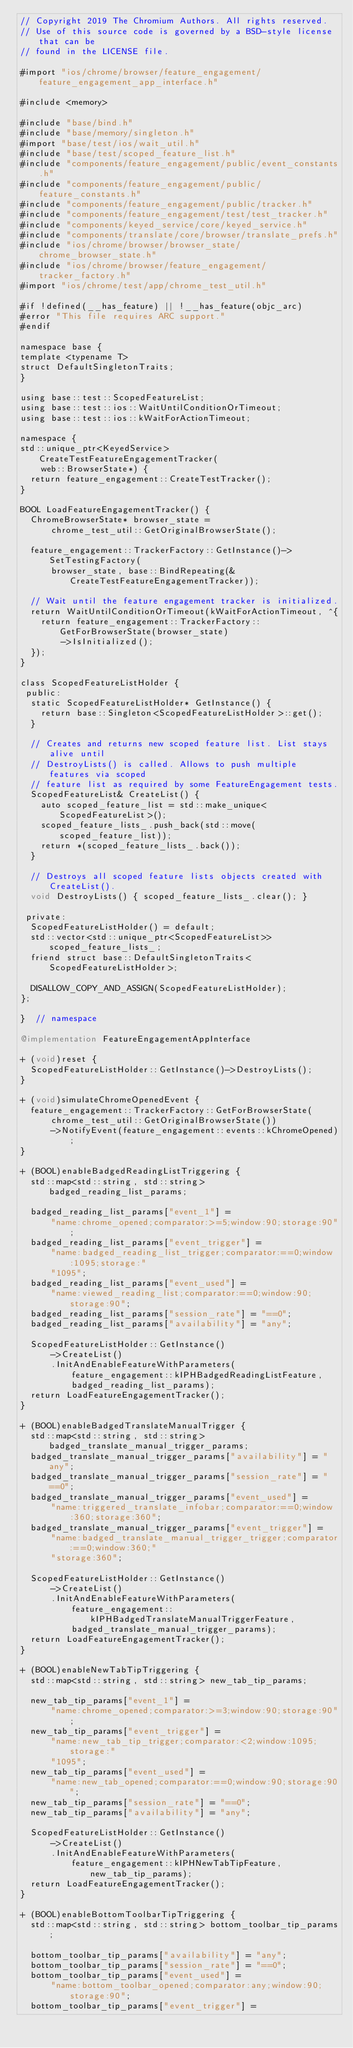<code> <loc_0><loc_0><loc_500><loc_500><_ObjectiveC_>// Copyright 2019 The Chromium Authors. All rights reserved.
// Use of this source code is governed by a BSD-style license that can be
// found in the LICENSE file.

#import "ios/chrome/browser/feature_engagement/feature_engagement_app_interface.h"

#include <memory>

#include "base/bind.h"
#include "base/memory/singleton.h"
#import "base/test/ios/wait_util.h"
#include "base/test/scoped_feature_list.h"
#include "components/feature_engagement/public/event_constants.h"
#include "components/feature_engagement/public/feature_constants.h"
#include "components/feature_engagement/public/tracker.h"
#include "components/feature_engagement/test/test_tracker.h"
#include "components/keyed_service/core/keyed_service.h"
#include "components/translate/core/browser/translate_prefs.h"
#include "ios/chrome/browser/browser_state/chrome_browser_state.h"
#include "ios/chrome/browser/feature_engagement/tracker_factory.h"
#import "ios/chrome/test/app/chrome_test_util.h"

#if !defined(__has_feature) || !__has_feature(objc_arc)
#error "This file requires ARC support."
#endif

namespace base {
template <typename T>
struct DefaultSingletonTraits;
}

using base::test::ScopedFeatureList;
using base::test::ios::WaitUntilConditionOrTimeout;
using base::test::ios::kWaitForActionTimeout;

namespace {
std::unique_ptr<KeyedService> CreateTestFeatureEngagementTracker(
    web::BrowserState*) {
  return feature_engagement::CreateTestTracker();
}

BOOL LoadFeatureEngagementTracker() {
  ChromeBrowserState* browser_state =
      chrome_test_util::GetOriginalBrowserState();

  feature_engagement::TrackerFactory::GetInstance()->SetTestingFactory(
      browser_state, base::BindRepeating(&CreateTestFeatureEngagementTracker));

  // Wait until the feature engagement tracker is initialized.
  return WaitUntilConditionOrTimeout(kWaitForActionTimeout, ^{
    return feature_engagement::TrackerFactory::GetForBrowserState(browser_state)
        ->IsInitialized();
  });
}

class ScopedFeatureListHolder {
 public:
  static ScopedFeatureListHolder* GetInstance() {
    return base::Singleton<ScopedFeatureListHolder>::get();
  }

  // Creates and returns new scoped feature list. List stays alive until
  // DestroyLists() is called. Allows to push multiple features via scoped
  // feature list as required by some FeatureEngagement tests.
  ScopedFeatureList& CreateList() {
    auto scoped_feature_list = std::make_unique<ScopedFeatureList>();
    scoped_feature_lists_.push_back(std::move(scoped_feature_list));
    return *(scoped_feature_lists_.back());
  }

  // Destroys all scoped feature lists objects created with CreateList().
  void DestroyLists() { scoped_feature_lists_.clear(); }

 private:
  ScopedFeatureListHolder() = default;
  std::vector<std::unique_ptr<ScopedFeatureList>> scoped_feature_lists_;
  friend struct base::DefaultSingletonTraits<ScopedFeatureListHolder>;

  DISALLOW_COPY_AND_ASSIGN(ScopedFeatureListHolder);
};

}  // namespace

@implementation FeatureEngagementAppInterface

+ (void)reset {
  ScopedFeatureListHolder::GetInstance()->DestroyLists();
}

+ (void)simulateChromeOpenedEvent {
  feature_engagement::TrackerFactory::GetForBrowserState(
      chrome_test_util::GetOriginalBrowserState())
      ->NotifyEvent(feature_engagement::events::kChromeOpened);
}

+ (BOOL)enableBadgedReadingListTriggering {
  std::map<std::string, std::string> badged_reading_list_params;

  badged_reading_list_params["event_1"] =
      "name:chrome_opened;comparator:>=5;window:90;storage:90";
  badged_reading_list_params["event_trigger"] =
      "name:badged_reading_list_trigger;comparator:==0;window:1095;storage:"
      "1095";
  badged_reading_list_params["event_used"] =
      "name:viewed_reading_list;comparator:==0;window:90;storage:90";
  badged_reading_list_params["session_rate"] = "==0";
  badged_reading_list_params["availability"] = "any";

  ScopedFeatureListHolder::GetInstance()
      ->CreateList()
      .InitAndEnableFeatureWithParameters(
          feature_engagement::kIPHBadgedReadingListFeature,
          badged_reading_list_params);
  return LoadFeatureEngagementTracker();
}

+ (BOOL)enableBadgedTranslateManualTrigger {
  std::map<std::string, std::string> badged_translate_manual_trigger_params;
  badged_translate_manual_trigger_params["availability"] = "any";
  badged_translate_manual_trigger_params["session_rate"] = "==0";
  badged_translate_manual_trigger_params["event_used"] =
      "name:triggered_translate_infobar;comparator:==0;window:360;storage:360";
  badged_translate_manual_trigger_params["event_trigger"] =
      "name:badged_translate_manual_trigger_trigger;comparator:==0;window:360;"
      "storage:360";

  ScopedFeatureListHolder::GetInstance()
      ->CreateList()
      .InitAndEnableFeatureWithParameters(
          feature_engagement::kIPHBadgedTranslateManualTriggerFeature,
          badged_translate_manual_trigger_params);
  return LoadFeatureEngagementTracker();
}

+ (BOOL)enableNewTabTipTriggering {
  std::map<std::string, std::string> new_tab_tip_params;

  new_tab_tip_params["event_1"] =
      "name:chrome_opened;comparator:>=3;window:90;storage:90";
  new_tab_tip_params["event_trigger"] =
      "name:new_tab_tip_trigger;comparator:<2;window:1095;storage:"
      "1095";
  new_tab_tip_params["event_used"] =
      "name:new_tab_opened;comparator:==0;window:90;storage:90";
  new_tab_tip_params["session_rate"] = "==0";
  new_tab_tip_params["availability"] = "any";

  ScopedFeatureListHolder::GetInstance()
      ->CreateList()
      .InitAndEnableFeatureWithParameters(
          feature_engagement::kIPHNewTabTipFeature, new_tab_tip_params);
  return LoadFeatureEngagementTracker();
}

+ (BOOL)enableBottomToolbarTipTriggering {
  std::map<std::string, std::string> bottom_toolbar_tip_params;

  bottom_toolbar_tip_params["availability"] = "any";
  bottom_toolbar_tip_params["session_rate"] = "==0";
  bottom_toolbar_tip_params["event_used"] =
      "name:bottom_toolbar_opened;comparator:any;window:90;storage:90";
  bottom_toolbar_tip_params["event_trigger"] =</code> 